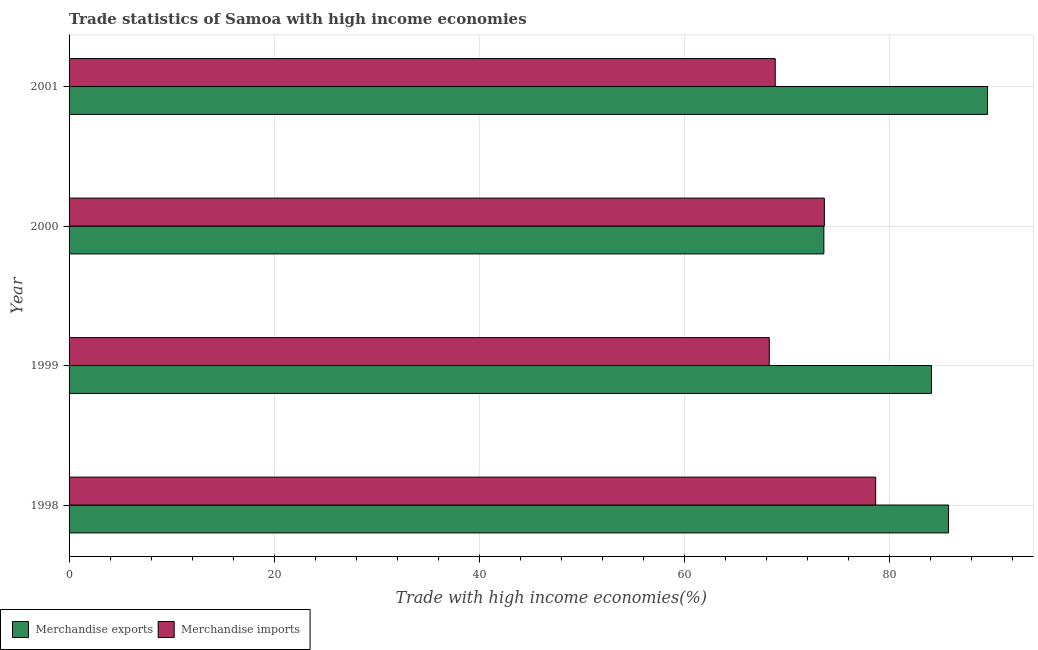How many different coloured bars are there?
Your answer should be compact. 2. How many groups of bars are there?
Make the answer very short. 4. Are the number of bars per tick equal to the number of legend labels?
Your answer should be very brief. Yes. How many bars are there on the 1st tick from the top?
Offer a very short reply. 2. How many bars are there on the 3rd tick from the bottom?
Provide a short and direct response. 2. What is the merchandise imports in 2000?
Keep it short and to the point. 73.67. Across all years, what is the maximum merchandise imports?
Provide a succinct answer. 78.68. Across all years, what is the minimum merchandise exports?
Offer a very short reply. 73.62. In which year was the merchandise exports maximum?
Make the answer very short. 2001. What is the total merchandise exports in the graph?
Provide a succinct answer. 333.12. What is the difference between the merchandise exports in 2000 and that in 2001?
Offer a terse response. -15.97. What is the difference between the merchandise imports in 1999 and the merchandise exports in 2000?
Provide a short and direct response. -5.32. What is the average merchandise imports per year?
Keep it short and to the point. 72.38. In the year 2000, what is the difference between the merchandise imports and merchandise exports?
Offer a very short reply. 0.05. In how many years, is the merchandise exports greater than 40 %?
Offer a terse response. 4. What is the ratio of the merchandise imports in 2000 to that in 2001?
Your answer should be compact. 1.07. Is the merchandise imports in 1998 less than that in 1999?
Keep it short and to the point. No. Is the difference between the merchandise exports in 2000 and 2001 greater than the difference between the merchandise imports in 2000 and 2001?
Offer a terse response. No. What is the difference between the highest and the second highest merchandise imports?
Your answer should be compact. 5.01. What is the difference between the highest and the lowest merchandise imports?
Your answer should be compact. 10.38. In how many years, is the merchandise exports greater than the average merchandise exports taken over all years?
Ensure brevity in your answer.  3. How many bars are there?
Your answer should be compact. 8. How many years are there in the graph?
Your answer should be very brief. 4. Are the values on the major ticks of X-axis written in scientific E-notation?
Give a very brief answer. No. What is the title of the graph?
Keep it short and to the point. Trade statistics of Samoa with high income economies. Does "Male labor force" appear as one of the legend labels in the graph?
Your response must be concise. No. What is the label or title of the X-axis?
Give a very brief answer. Trade with high income economies(%). What is the label or title of the Y-axis?
Ensure brevity in your answer.  Year. What is the Trade with high income economies(%) of Merchandise exports in 1998?
Make the answer very short. 85.79. What is the Trade with high income economies(%) of Merchandise imports in 1998?
Keep it short and to the point. 78.68. What is the Trade with high income economies(%) in Merchandise exports in 1999?
Your answer should be very brief. 84.12. What is the Trade with high income economies(%) in Merchandise imports in 1999?
Provide a succinct answer. 68.3. What is the Trade with high income economies(%) of Merchandise exports in 2000?
Make the answer very short. 73.62. What is the Trade with high income economies(%) in Merchandise imports in 2000?
Offer a very short reply. 73.67. What is the Trade with high income economies(%) in Merchandise exports in 2001?
Give a very brief answer. 89.59. What is the Trade with high income economies(%) in Merchandise imports in 2001?
Ensure brevity in your answer.  68.88. Across all years, what is the maximum Trade with high income economies(%) of Merchandise exports?
Your answer should be compact. 89.59. Across all years, what is the maximum Trade with high income economies(%) of Merchandise imports?
Offer a very short reply. 78.68. Across all years, what is the minimum Trade with high income economies(%) of Merchandise exports?
Ensure brevity in your answer.  73.62. Across all years, what is the minimum Trade with high income economies(%) in Merchandise imports?
Make the answer very short. 68.3. What is the total Trade with high income economies(%) in Merchandise exports in the graph?
Your answer should be compact. 333.12. What is the total Trade with high income economies(%) in Merchandise imports in the graph?
Your response must be concise. 289.53. What is the difference between the Trade with high income economies(%) in Merchandise exports in 1998 and that in 1999?
Offer a terse response. 1.66. What is the difference between the Trade with high income economies(%) in Merchandise imports in 1998 and that in 1999?
Ensure brevity in your answer.  10.38. What is the difference between the Trade with high income economies(%) in Merchandise exports in 1998 and that in 2000?
Provide a succinct answer. 12.16. What is the difference between the Trade with high income economies(%) in Merchandise imports in 1998 and that in 2000?
Provide a succinct answer. 5.01. What is the difference between the Trade with high income economies(%) of Merchandise exports in 1998 and that in 2001?
Keep it short and to the point. -3.81. What is the difference between the Trade with high income economies(%) of Merchandise imports in 1998 and that in 2001?
Give a very brief answer. 9.8. What is the difference between the Trade with high income economies(%) of Merchandise exports in 1999 and that in 2000?
Keep it short and to the point. 10.5. What is the difference between the Trade with high income economies(%) in Merchandise imports in 1999 and that in 2000?
Your answer should be compact. -5.37. What is the difference between the Trade with high income economies(%) of Merchandise exports in 1999 and that in 2001?
Give a very brief answer. -5.47. What is the difference between the Trade with high income economies(%) in Merchandise imports in 1999 and that in 2001?
Provide a short and direct response. -0.58. What is the difference between the Trade with high income economies(%) of Merchandise exports in 2000 and that in 2001?
Provide a succinct answer. -15.97. What is the difference between the Trade with high income economies(%) of Merchandise imports in 2000 and that in 2001?
Ensure brevity in your answer.  4.79. What is the difference between the Trade with high income economies(%) in Merchandise exports in 1998 and the Trade with high income economies(%) in Merchandise imports in 1999?
Provide a short and direct response. 17.49. What is the difference between the Trade with high income economies(%) of Merchandise exports in 1998 and the Trade with high income economies(%) of Merchandise imports in 2000?
Provide a succinct answer. 12.11. What is the difference between the Trade with high income economies(%) in Merchandise exports in 1998 and the Trade with high income economies(%) in Merchandise imports in 2001?
Offer a terse response. 16.9. What is the difference between the Trade with high income economies(%) of Merchandise exports in 1999 and the Trade with high income economies(%) of Merchandise imports in 2000?
Keep it short and to the point. 10.45. What is the difference between the Trade with high income economies(%) in Merchandise exports in 1999 and the Trade with high income economies(%) in Merchandise imports in 2001?
Ensure brevity in your answer.  15.24. What is the difference between the Trade with high income economies(%) of Merchandise exports in 2000 and the Trade with high income economies(%) of Merchandise imports in 2001?
Offer a terse response. 4.74. What is the average Trade with high income economies(%) in Merchandise exports per year?
Provide a short and direct response. 83.28. What is the average Trade with high income economies(%) of Merchandise imports per year?
Your response must be concise. 72.38. In the year 1998, what is the difference between the Trade with high income economies(%) of Merchandise exports and Trade with high income economies(%) of Merchandise imports?
Your response must be concise. 7.11. In the year 1999, what is the difference between the Trade with high income economies(%) in Merchandise exports and Trade with high income economies(%) in Merchandise imports?
Give a very brief answer. 15.82. In the year 2000, what is the difference between the Trade with high income economies(%) of Merchandise exports and Trade with high income economies(%) of Merchandise imports?
Provide a succinct answer. -0.05. In the year 2001, what is the difference between the Trade with high income economies(%) of Merchandise exports and Trade with high income economies(%) of Merchandise imports?
Provide a succinct answer. 20.71. What is the ratio of the Trade with high income economies(%) of Merchandise exports in 1998 to that in 1999?
Provide a succinct answer. 1.02. What is the ratio of the Trade with high income economies(%) of Merchandise imports in 1998 to that in 1999?
Your answer should be compact. 1.15. What is the ratio of the Trade with high income economies(%) of Merchandise exports in 1998 to that in 2000?
Your response must be concise. 1.17. What is the ratio of the Trade with high income economies(%) of Merchandise imports in 1998 to that in 2000?
Ensure brevity in your answer.  1.07. What is the ratio of the Trade with high income economies(%) in Merchandise exports in 1998 to that in 2001?
Your response must be concise. 0.96. What is the ratio of the Trade with high income economies(%) of Merchandise imports in 1998 to that in 2001?
Your response must be concise. 1.14. What is the ratio of the Trade with high income economies(%) in Merchandise exports in 1999 to that in 2000?
Your answer should be compact. 1.14. What is the ratio of the Trade with high income economies(%) in Merchandise imports in 1999 to that in 2000?
Provide a short and direct response. 0.93. What is the ratio of the Trade with high income economies(%) in Merchandise exports in 1999 to that in 2001?
Provide a short and direct response. 0.94. What is the ratio of the Trade with high income economies(%) of Merchandise imports in 1999 to that in 2001?
Your answer should be compact. 0.99. What is the ratio of the Trade with high income economies(%) in Merchandise exports in 2000 to that in 2001?
Keep it short and to the point. 0.82. What is the ratio of the Trade with high income economies(%) of Merchandise imports in 2000 to that in 2001?
Your response must be concise. 1.07. What is the difference between the highest and the second highest Trade with high income economies(%) in Merchandise exports?
Make the answer very short. 3.81. What is the difference between the highest and the second highest Trade with high income economies(%) in Merchandise imports?
Provide a short and direct response. 5.01. What is the difference between the highest and the lowest Trade with high income economies(%) in Merchandise exports?
Your response must be concise. 15.97. What is the difference between the highest and the lowest Trade with high income economies(%) in Merchandise imports?
Offer a terse response. 10.38. 